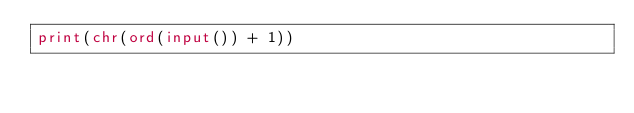Convert code to text. <code><loc_0><loc_0><loc_500><loc_500><_Python_>print(chr(ord(input()) + 1))</code> 